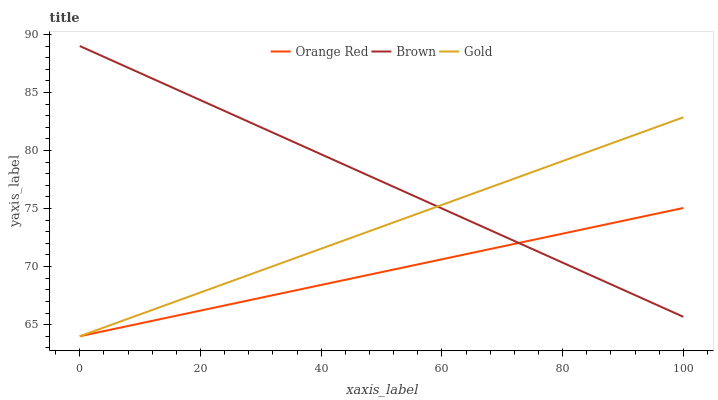Does Orange Red have the minimum area under the curve?
Answer yes or no. Yes. Does Brown have the maximum area under the curve?
Answer yes or no. Yes. Does Gold have the minimum area under the curve?
Answer yes or no. No. Does Gold have the maximum area under the curve?
Answer yes or no. No. Is Gold the smoothest?
Answer yes or no. Yes. Is Orange Red the roughest?
Answer yes or no. Yes. Is Orange Red the smoothest?
Answer yes or no. No. Is Gold the roughest?
Answer yes or no. No. Does Orange Red have the lowest value?
Answer yes or no. Yes. Does Brown have the highest value?
Answer yes or no. Yes. Does Gold have the highest value?
Answer yes or no. No. Does Gold intersect Orange Red?
Answer yes or no. Yes. Is Gold less than Orange Red?
Answer yes or no. No. Is Gold greater than Orange Red?
Answer yes or no. No. 